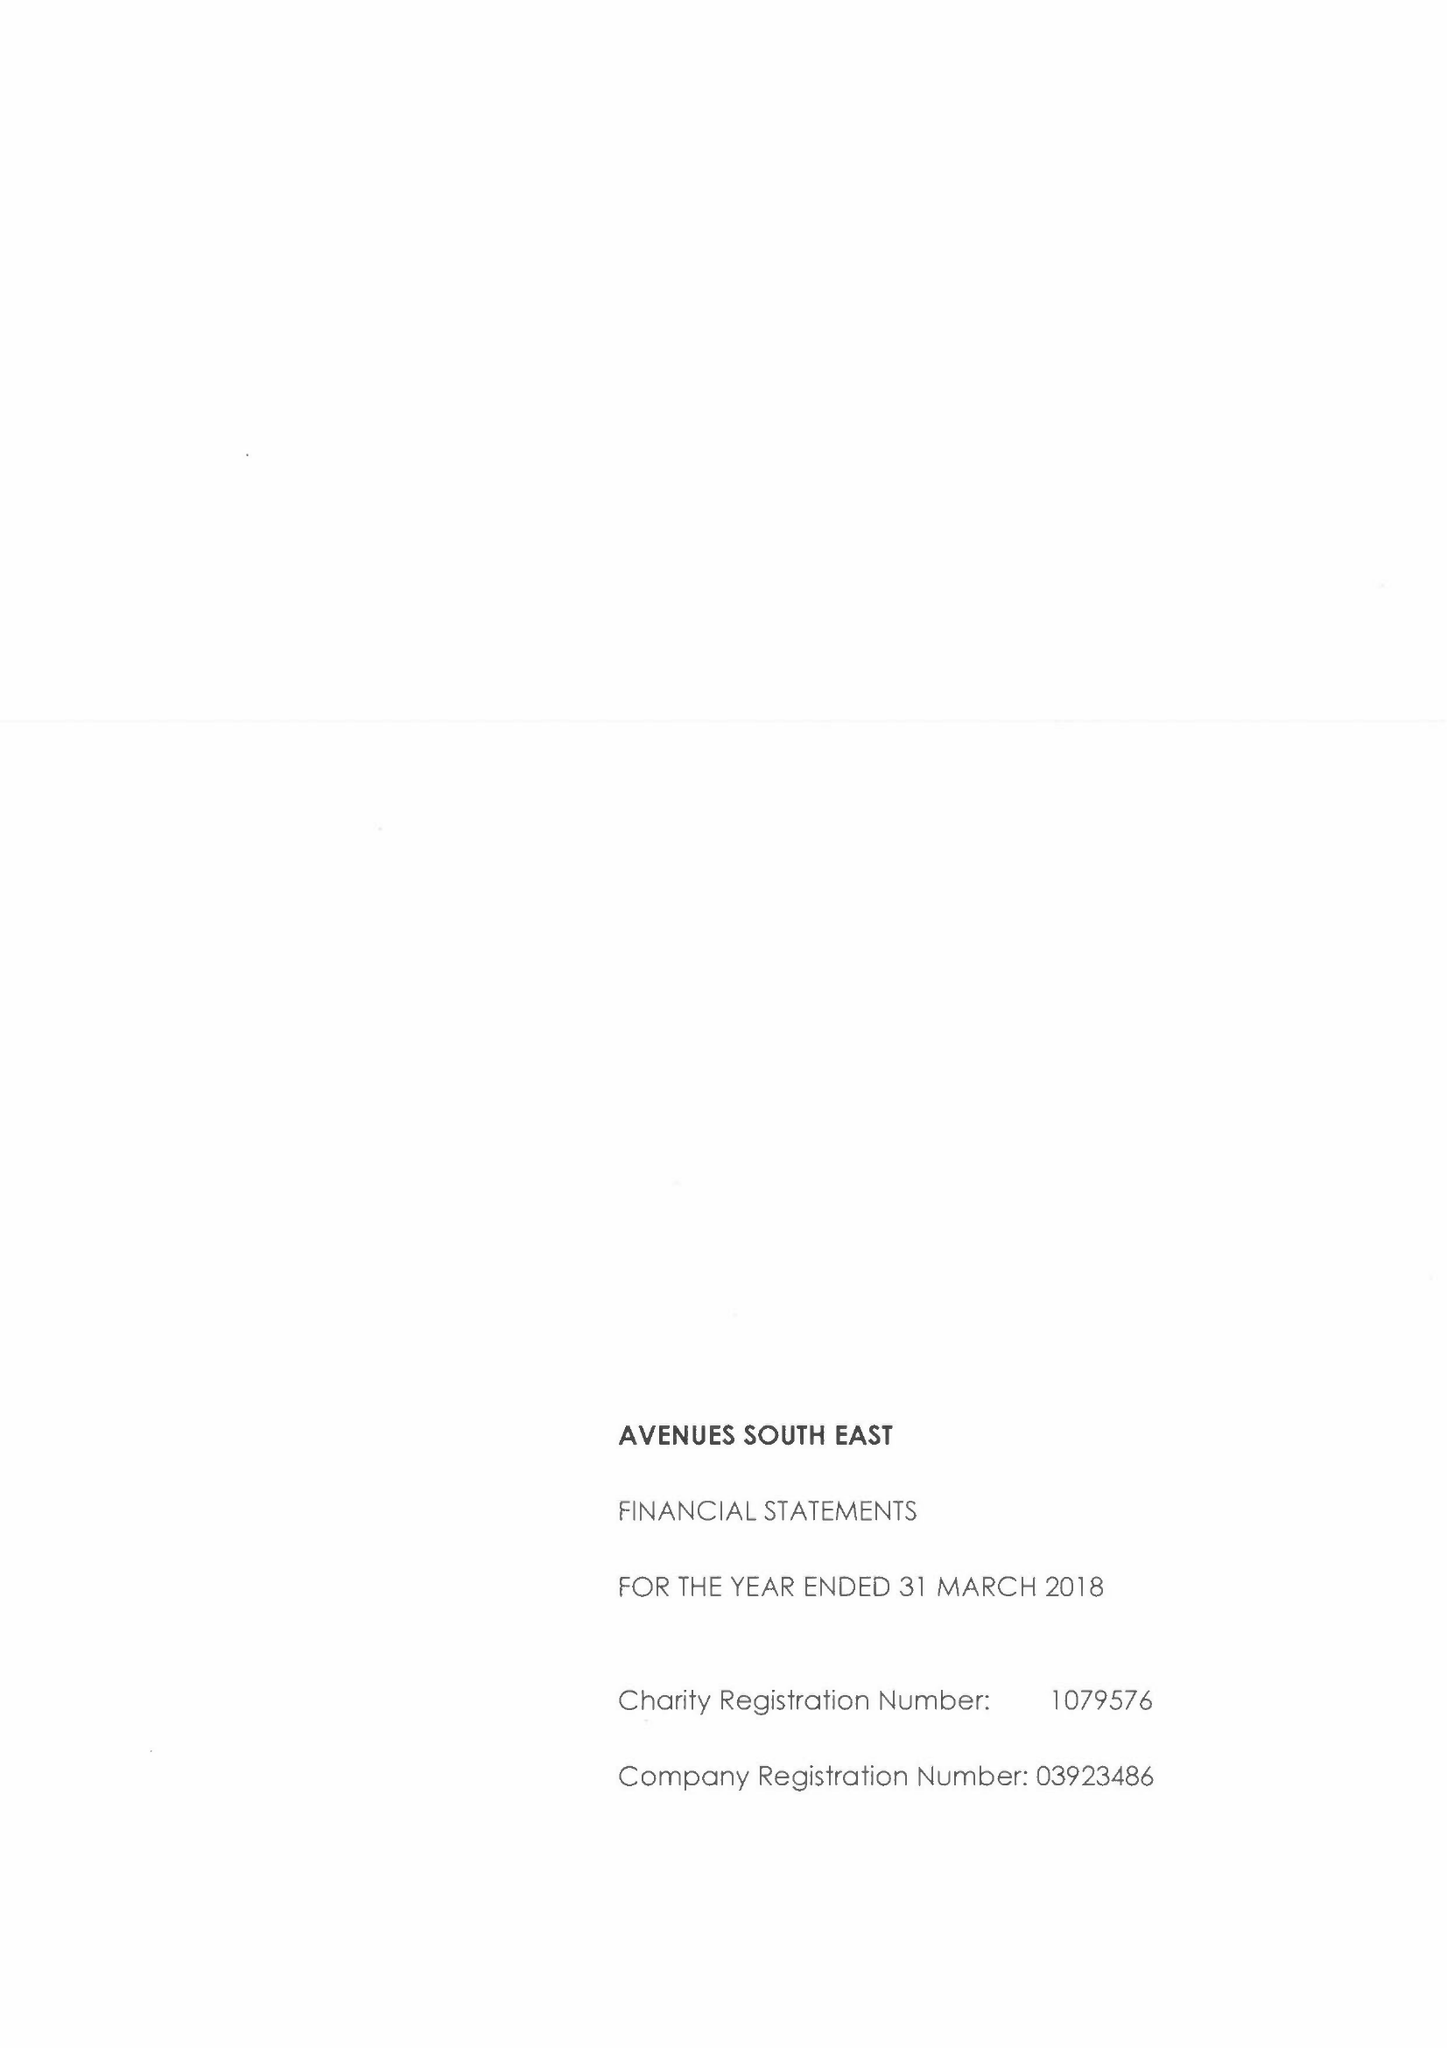What is the value for the income_annually_in_british_pounds?
Answer the question using a single word or phrase. 15783000.00 